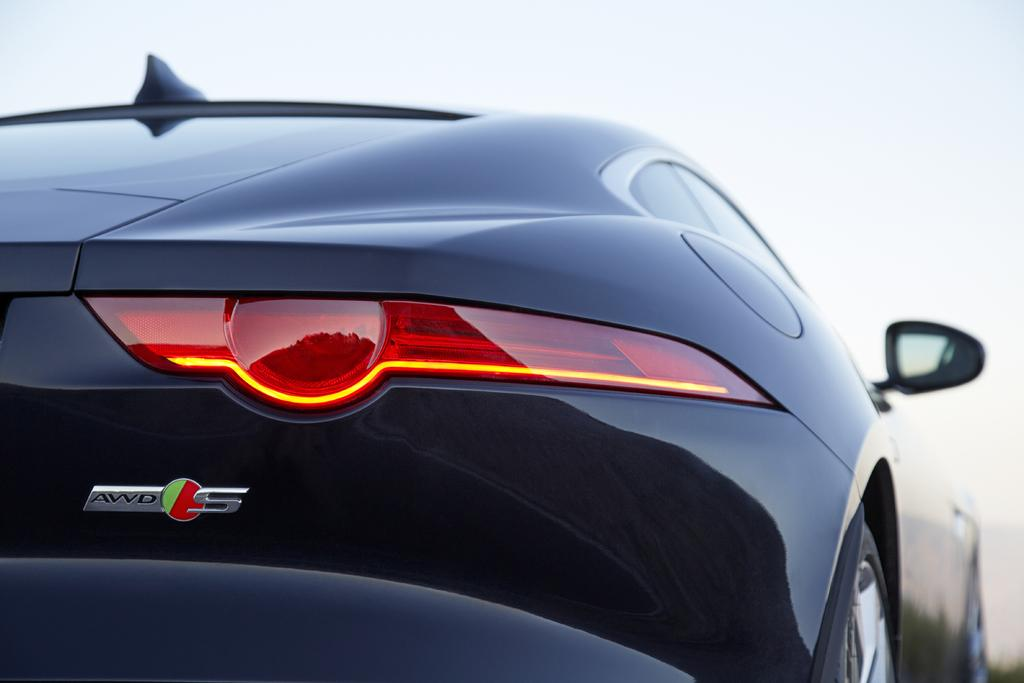What type of vehicle is in the image? There is a black car in the image. What object is present that is commonly used for personal grooming? There is a mirror in the image. What part of the car is designed to indicate when the driver is braking? There is a brake light in the image. What type of roof can be seen on the car in the image? The image does not show the roof of the car, so it cannot be determined from the image. 